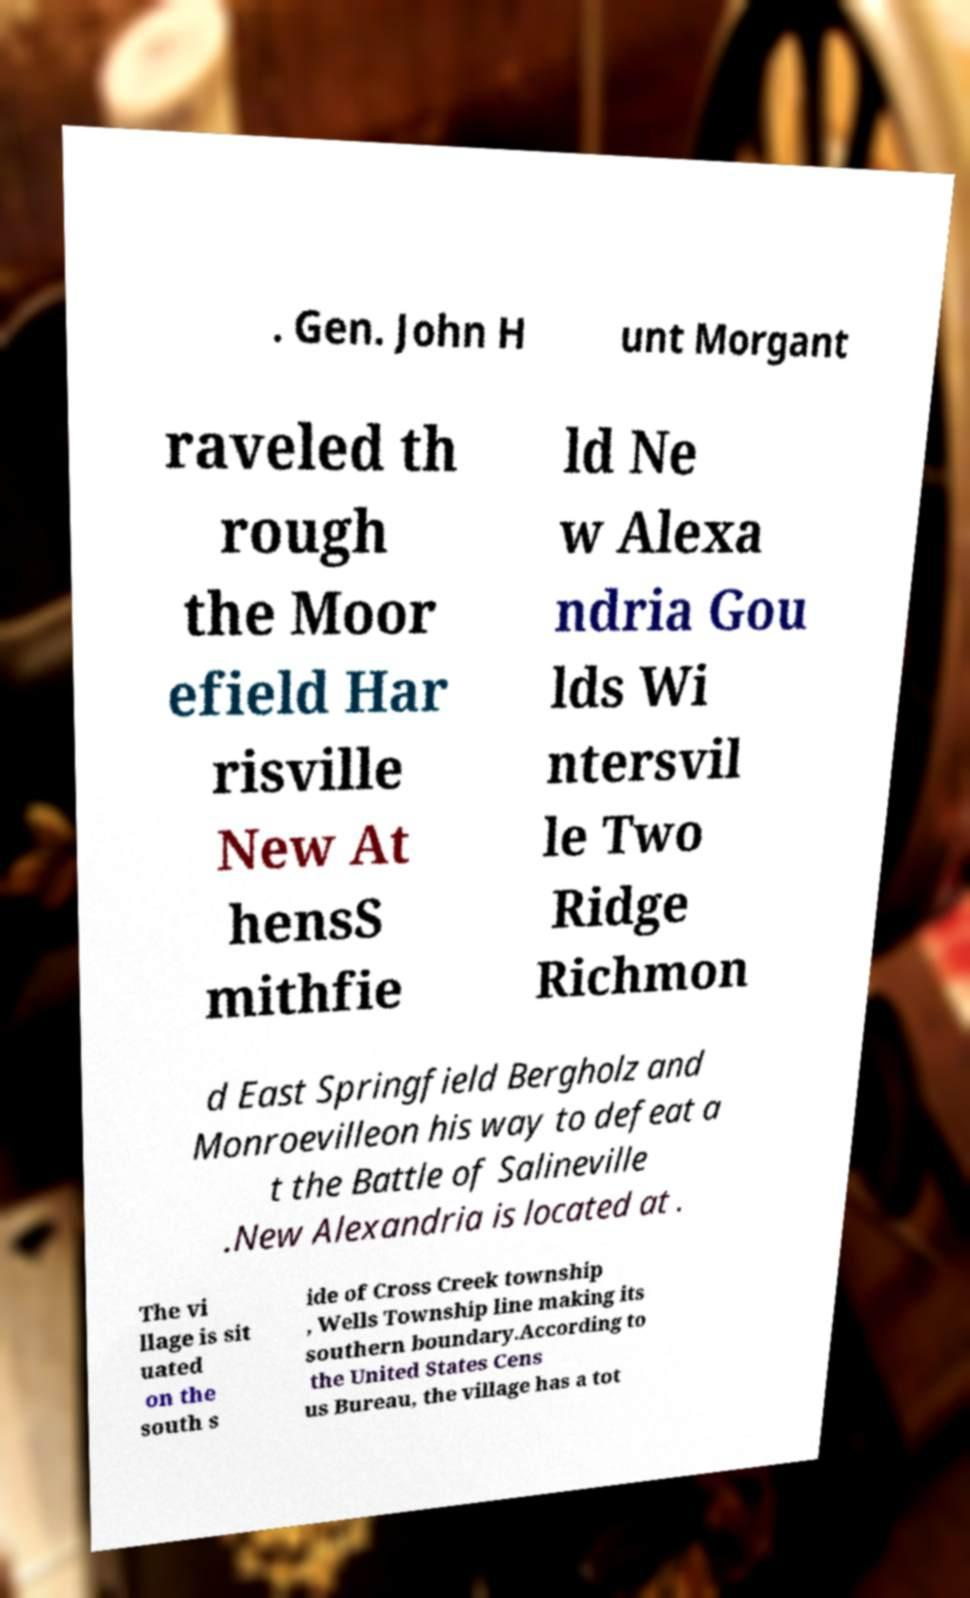Can you read and provide the text displayed in the image?This photo seems to have some interesting text. Can you extract and type it out for me? . Gen. John H unt Morgant raveled th rough the Moor efield Har risville New At hensS mithfie ld Ne w Alexa ndria Gou lds Wi ntersvil le Two Ridge Richmon d East Springfield Bergholz and Monroevilleon his way to defeat a t the Battle of Salineville .New Alexandria is located at . The vi llage is sit uated on the south s ide of Cross Creek township , Wells Township line making its southern boundary.According to the United States Cens us Bureau, the village has a tot 